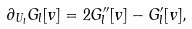<formula> <loc_0><loc_0><loc_500><loc_500>\partial _ { U _ { l } } G _ { l } [ v ] = 2 G ^ { \prime \prime } _ { l } [ v ] - G ^ { \prime } _ { l } [ v ] , \</formula> 